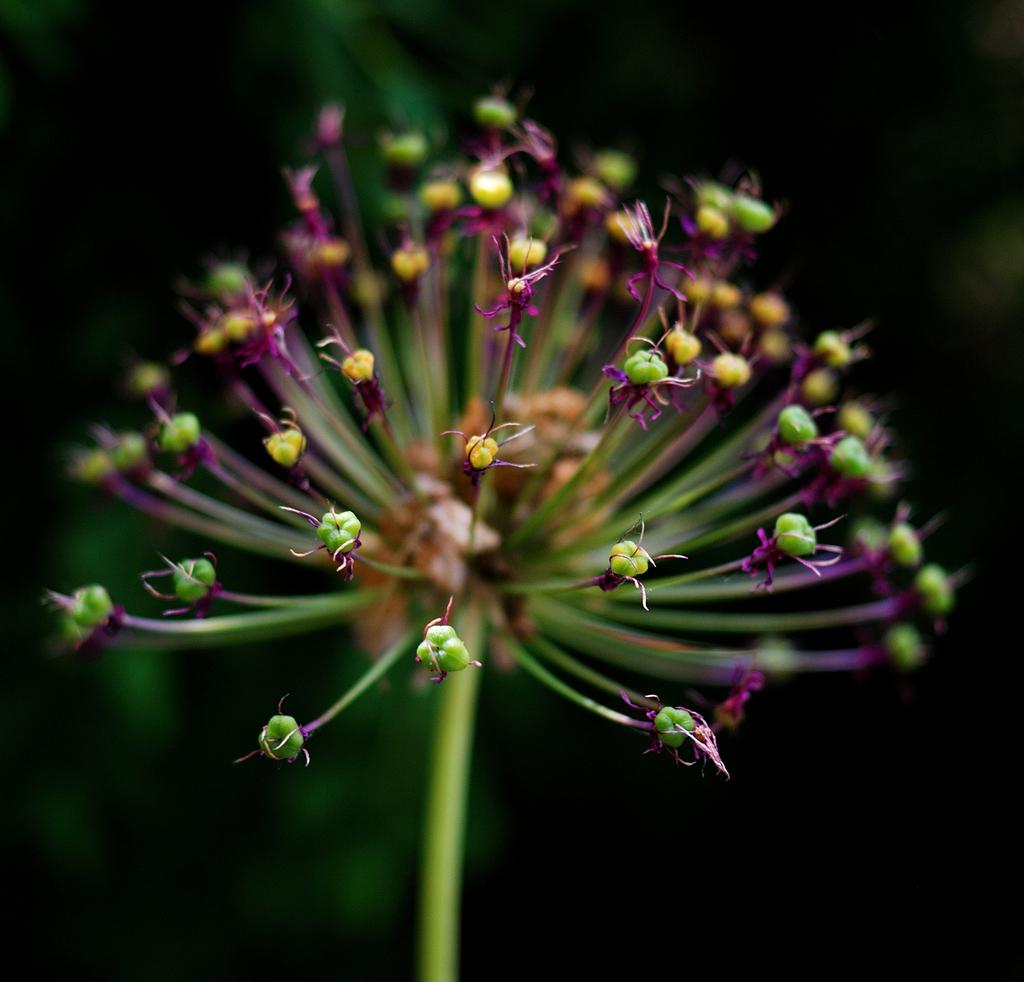What is present in the image? There are buds in the image. What can be observed about the background of the image? The background of the image is dark. What is the income of the buds in the image? There is no information about the income of the buds in the image, as they are not living beings with an income. 